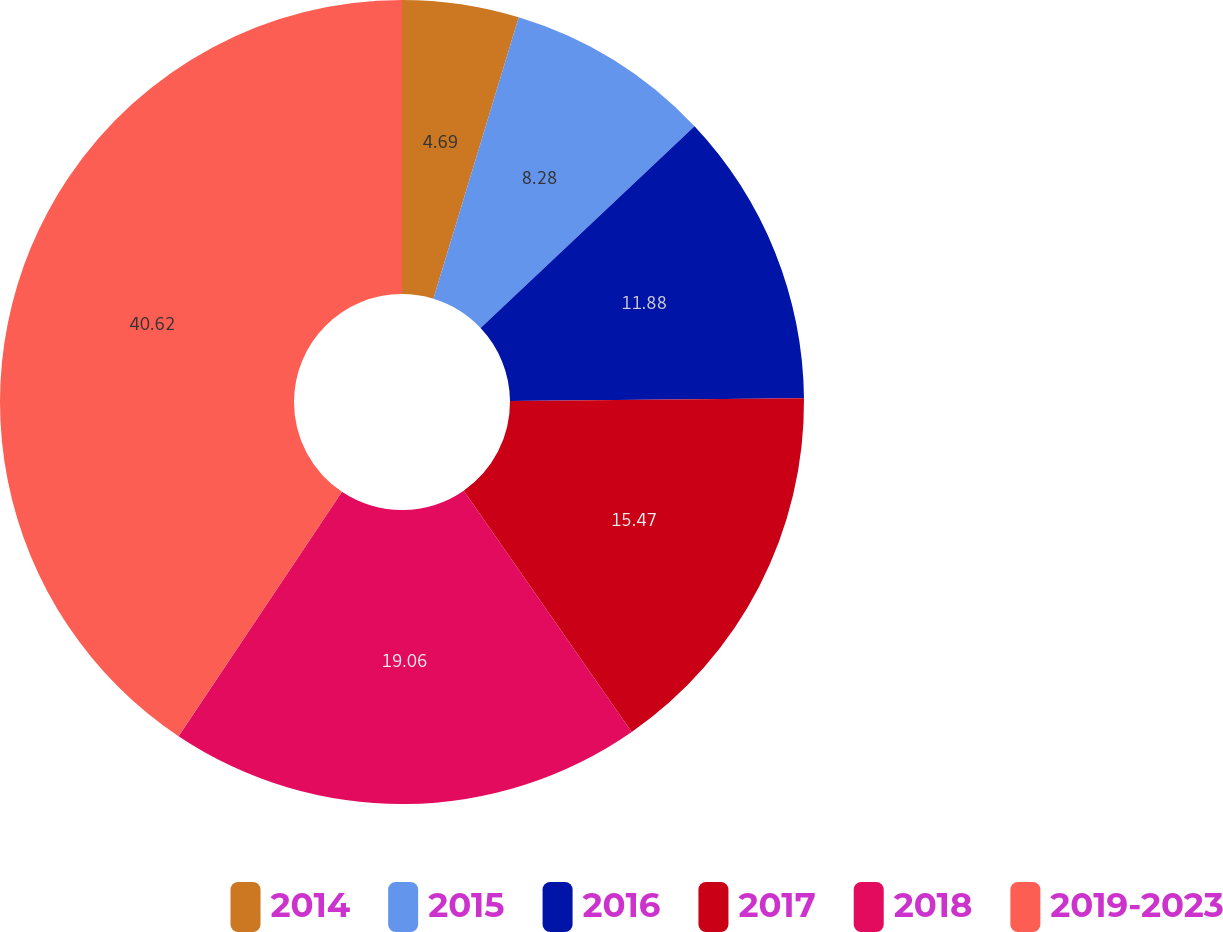Convert chart to OTSL. <chart><loc_0><loc_0><loc_500><loc_500><pie_chart><fcel>2014<fcel>2015<fcel>2016<fcel>2017<fcel>2018<fcel>2019-2023<nl><fcel>4.69%<fcel>8.28%<fcel>11.88%<fcel>15.47%<fcel>19.06%<fcel>40.62%<nl></chart> 